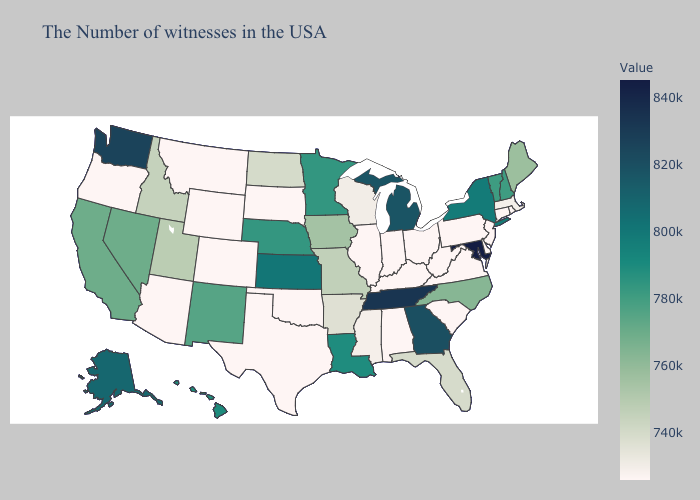Which states hav the highest value in the South?
Be succinct. Maryland. Among the states that border Kansas , does Missouri have the lowest value?
Keep it brief. No. Is the legend a continuous bar?
Concise answer only. Yes. Which states hav the highest value in the South?
Answer briefly. Maryland. Does Michigan have the highest value in the MidWest?
Concise answer only. Yes. Does Oregon have the highest value in the West?
Give a very brief answer. No. 